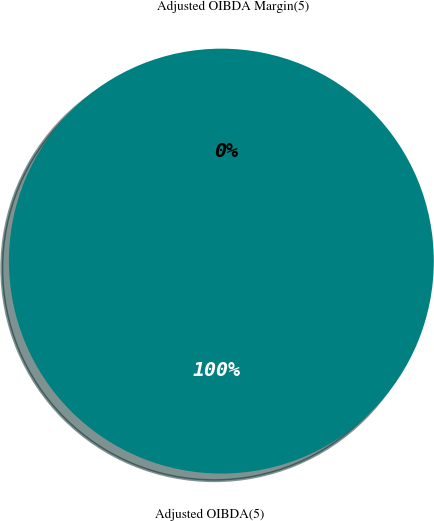Convert chart to OTSL. <chart><loc_0><loc_0><loc_500><loc_500><pie_chart><fcel>Adjusted OIBDA(5)<fcel>Adjusted OIBDA Margin(5)<nl><fcel>100.0%<fcel>0.0%<nl></chart> 